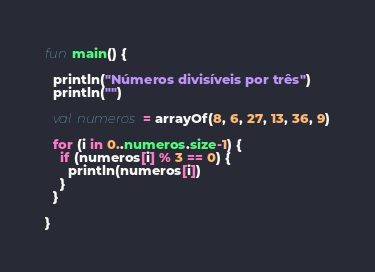<code> <loc_0><loc_0><loc_500><loc_500><_Kotlin_>fun main() {

  println("Números divisíveis por três")
  println("")

  val numeros = arrayOf(8, 6, 27, 13, 36, 9)

  for (i in 0..numeros.size-1) {
    if (numeros[i] % 3 == 0) {
      println(numeros[i])
    }
  }

}
</code> 